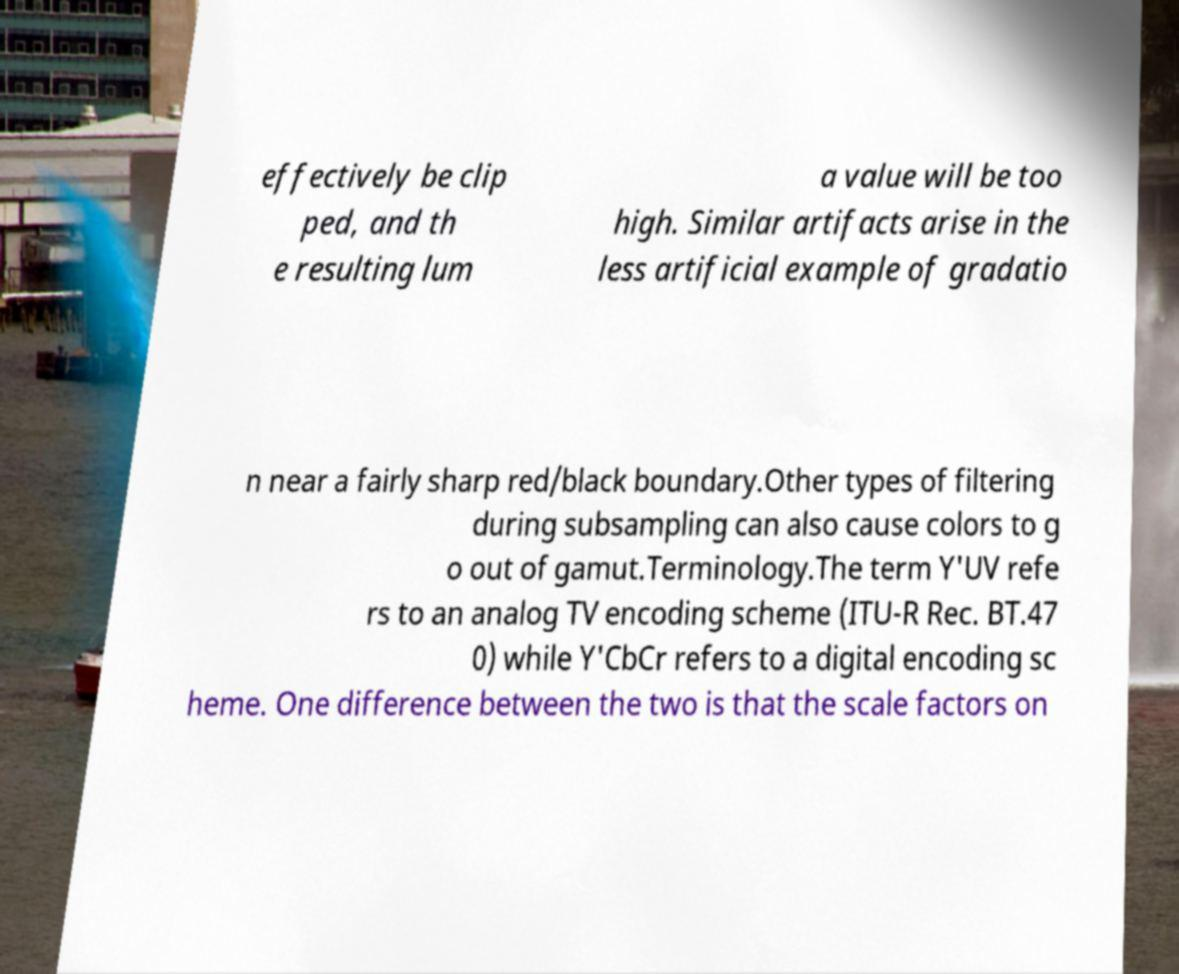For documentation purposes, I need the text within this image transcribed. Could you provide that? effectively be clip ped, and th e resulting lum a value will be too high. Similar artifacts arise in the less artificial example of gradatio n near a fairly sharp red/black boundary.Other types of filtering during subsampling can also cause colors to g o out of gamut.Terminology.The term Y'UV refe rs to an analog TV encoding scheme (ITU-R Rec. BT.47 0) while Y'CbCr refers to a digital encoding sc heme. One difference between the two is that the scale factors on 